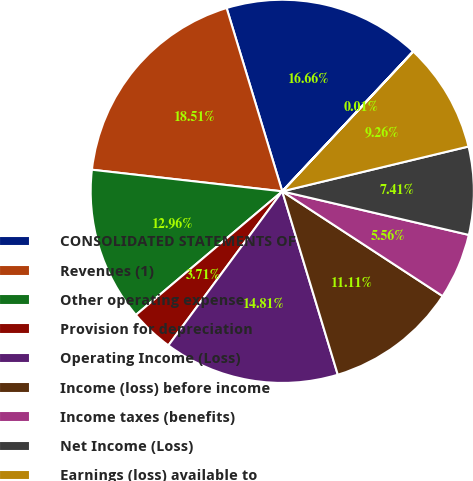<chart> <loc_0><loc_0><loc_500><loc_500><pie_chart><fcel>CONSOLIDATED STATEMENTS OF<fcel>Revenues (1)<fcel>Other operating expense<fcel>Provision for depreciation<fcel>Operating Income (Loss)<fcel>Income (loss) before income<fcel>Income taxes (benefits)<fcel>Net Income (Loss)<fcel>Earnings (loss) available to<fcel>Basic<nl><fcel>16.66%<fcel>18.51%<fcel>12.96%<fcel>3.71%<fcel>14.81%<fcel>11.11%<fcel>5.56%<fcel>7.41%<fcel>9.26%<fcel>0.01%<nl></chart> 